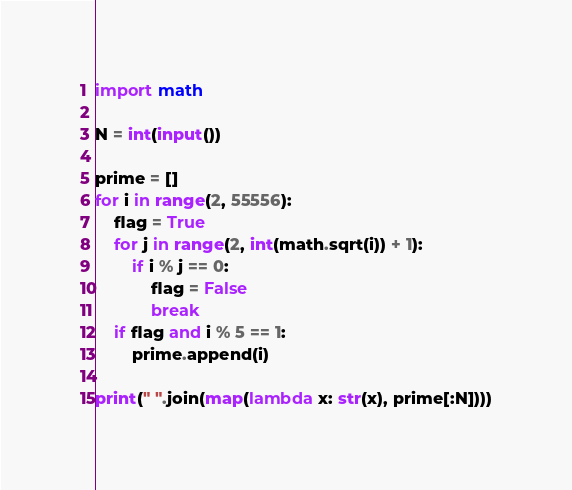Convert code to text. <code><loc_0><loc_0><loc_500><loc_500><_Python_>import math

N = int(input())

prime = []
for i in range(2, 55556):
    flag = True
    for j in range(2, int(math.sqrt(i)) + 1):
        if i % j == 0:
            flag = False
            break
    if flag and i % 5 == 1:
        prime.append(i)

print(" ".join(map(lambda x: str(x), prime[:N])))
</code> 